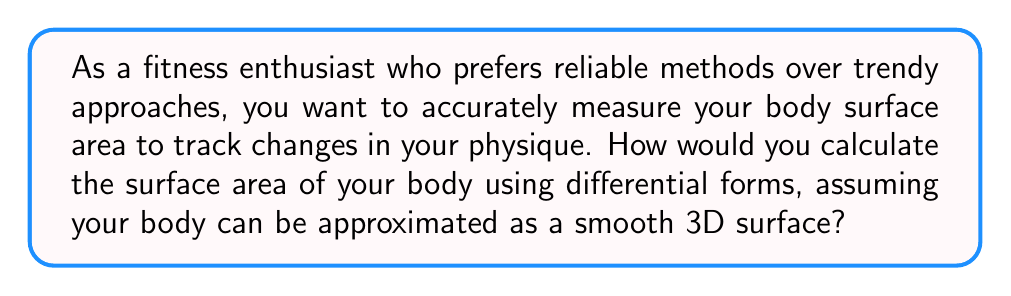Give your solution to this math problem. To calculate the surface area of a human body using differential forms, we'll follow these steps:

1. Model the body as a smooth 3D surface $S$ in $\mathbb{R}^3$.

2. Choose a parameterization of the surface:
   Let $\mathbf{r}(u,v) = (x(u,v), y(u,v), z(u,v))$ be a parameterization of $S$, where $(u,v)$ are in some region $D$ of $\mathbb{R}^2$.

3. Calculate the tangent vectors:
   $\mathbf{r}_u = (\frac{\partial x}{\partial u}, \frac{\partial y}{\partial u}, \frac{\partial z}{\partial u})$
   $\mathbf{r}_v = (\frac{\partial x}{\partial v}, \frac{\partial y}{\partial v}, \frac{\partial z}{\partial v})$

4. Compute the normal vector:
   $\mathbf{N} = \mathbf{r}_u \times \mathbf{r}_v$

5. Calculate the magnitude of the normal vector:
   $\|\mathbf{N}\| = \sqrt{(\frac{\partial y}{\partial u}\frac{\partial z}{\partial v} - \frac{\partial z}{\partial u}\frac{\partial y}{\partial v})^2 + (\frac{\partial z}{\partial u}\frac{\partial x}{\partial v} - \frac{\partial x}{\partial u}\frac{\partial z}{\partial v})^2 + (\frac{\partial x}{\partial u}\frac{\partial y}{\partial v} - \frac{\partial y}{\partial u}\frac{\partial x}{\partial v})^2}$

6. Define the area element:
   $dA = \|\mathbf{N}\| du dv$

7. Integrate the area element over the parameter region $D$:
   $$\text{Surface Area} = \iint_D \|\mathbf{N}\| du dv$$

This method provides an accurate and scientifically-based approach to calculating body surface area, avoiding trendy or unreliable techniques.
Answer: $$\text{Surface Area} = \iint_D \|\mathbf{N}\| du dv$$ 